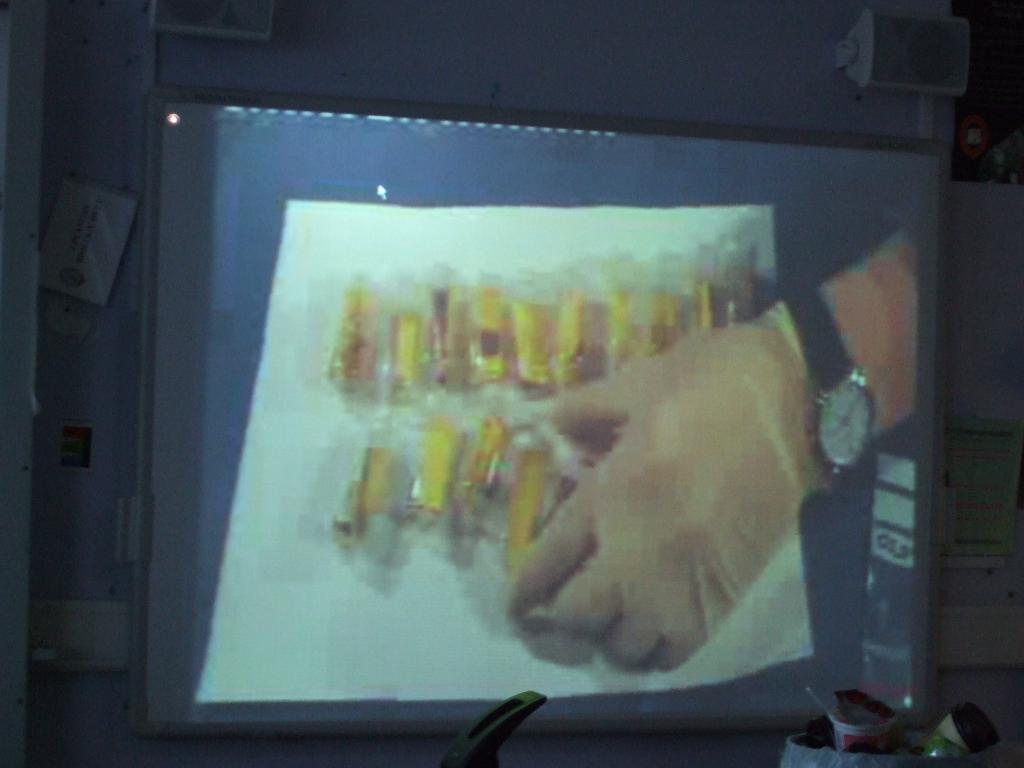Could you give a brief overview of what you see in this image? In the image we can see the screen, we can even see a person's hand, wearing a wristwatch and gloves, and holding an object in hand. There are sound boxes and there are other things. 